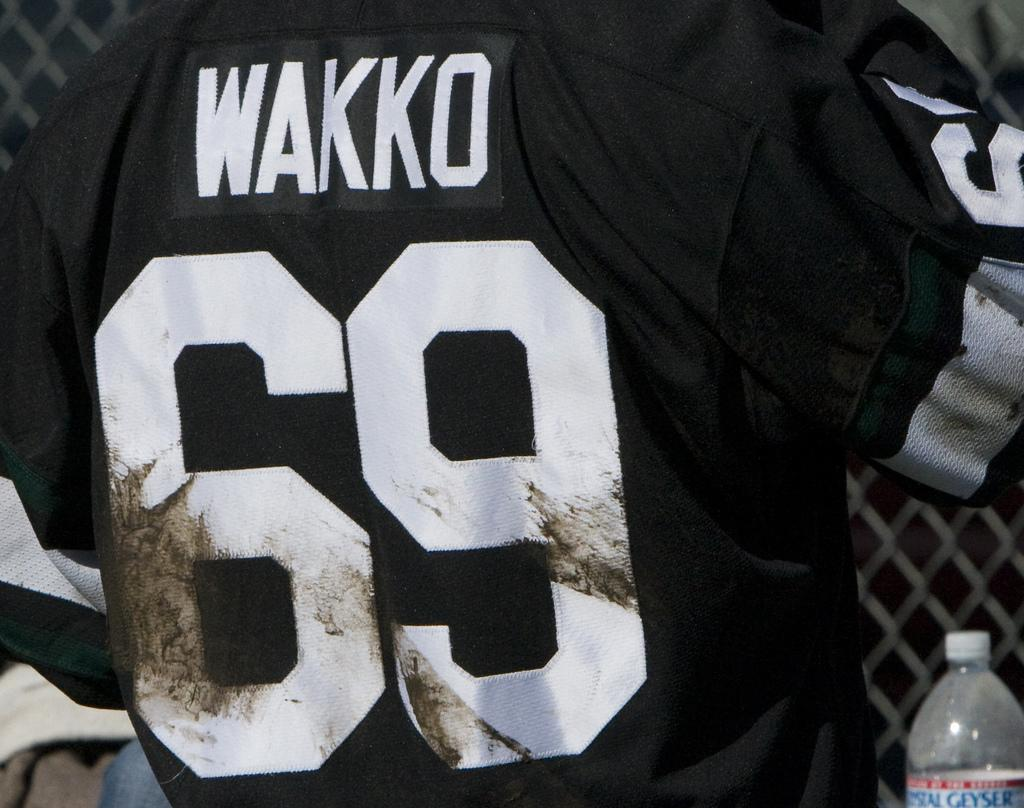Provide a one-sentence caption for the provided image. Football player Wakko wears a black jersey with number 69. 